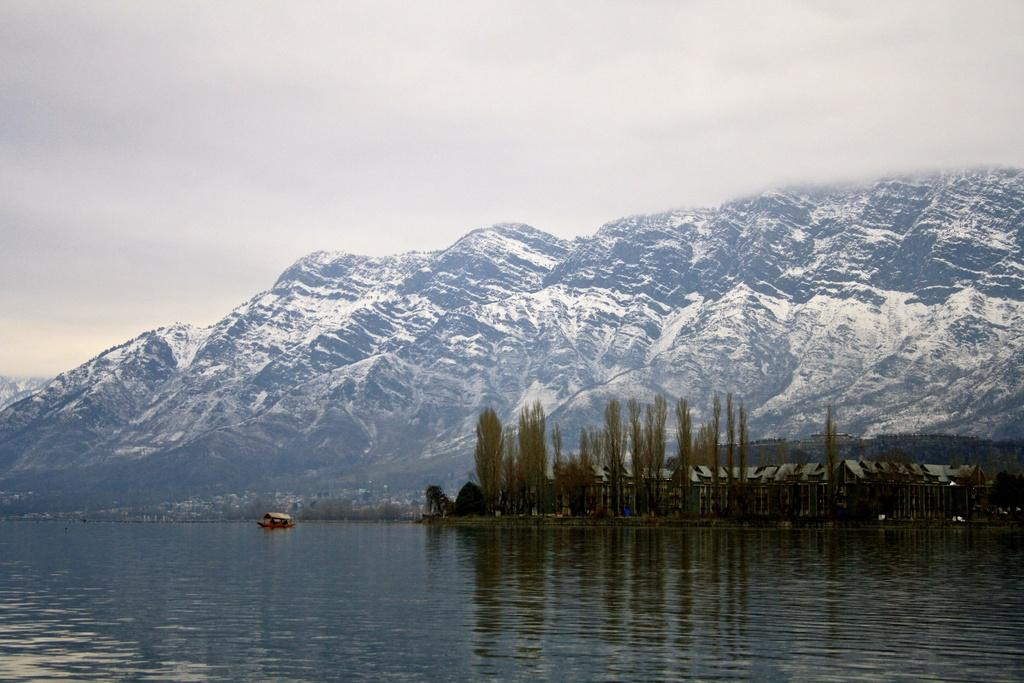What is the main subject of the image? The main subject of the image is a boat. Where is the boat located? The boat is on the water. What other natural elements can be seen in the image? There are trees, mountains, and the sky visible in the image. What man-made structures are present in the image? There are sheds in the image. Are there any other objects visible in the image? Yes, there are objects in the image. What type of base is used to support the drink in the image? There is no drink present in the image, so it is not possible to determine the type of base used to support it. 